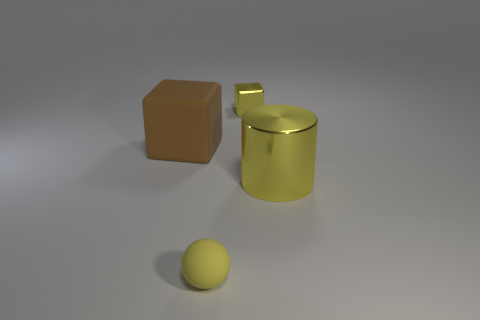Add 4 large yellow cubes. How many objects exist? 8 Subtract all balls. How many objects are left? 3 Subtract all green balls. Subtract all yellow cylinders. How many balls are left? 1 Subtract all yellow matte things. Subtract all big brown things. How many objects are left? 2 Add 2 tiny rubber things. How many tiny rubber things are left? 3 Add 3 cylinders. How many cylinders exist? 4 Subtract 0 green spheres. How many objects are left? 4 